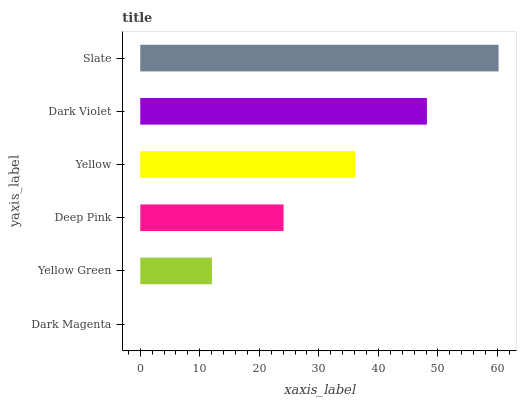Is Dark Magenta the minimum?
Answer yes or no. Yes. Is Slate the maximum?
Answer yes or no. Yes. Is Yellow Green the minimum?
Answer yes or no. No. Is Yellow Green the maximum?
Answer yes or no. No. Is Yellow Green greater than Dark Magenta?
Answer yes or no. Yes. Is Dark Magenta less than Yellow Green?
Answer yes or no. Yes. Is Dark Magenta greater than Yellow Green?
Answer yes or no. No. Is Yellow Green less than Dark Magenta?
Answer yes or no. No. Is Yellow the high median?
Answer yes or no. Yes. Is Deep Pink the low median?
Answer yes or no. Yes. Is Slate the high median?
Answer yes or no. No. Is Yellow the low median?
Answer yes or no. No. 